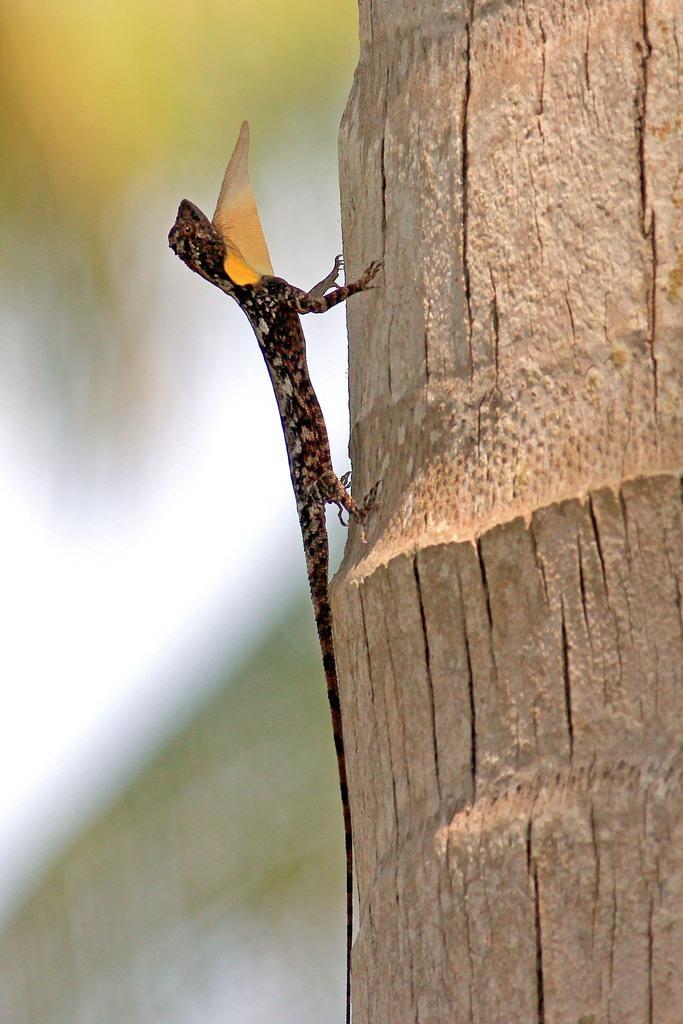Could you give a brief overview of what you see in this image? In the center of the image a garden lizard is there. On the right side of the image tree is present. 